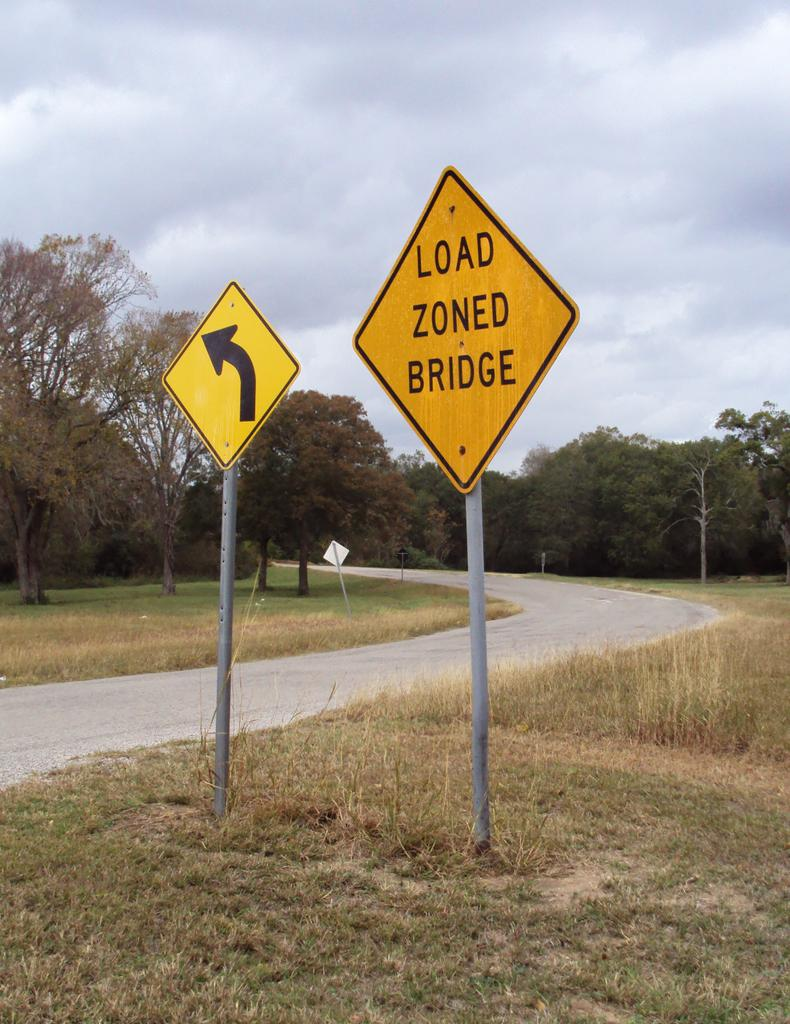<image>
Relay a brief, clear account of the picture shown. Street signs, one of which says Load Zoned Bridge. 